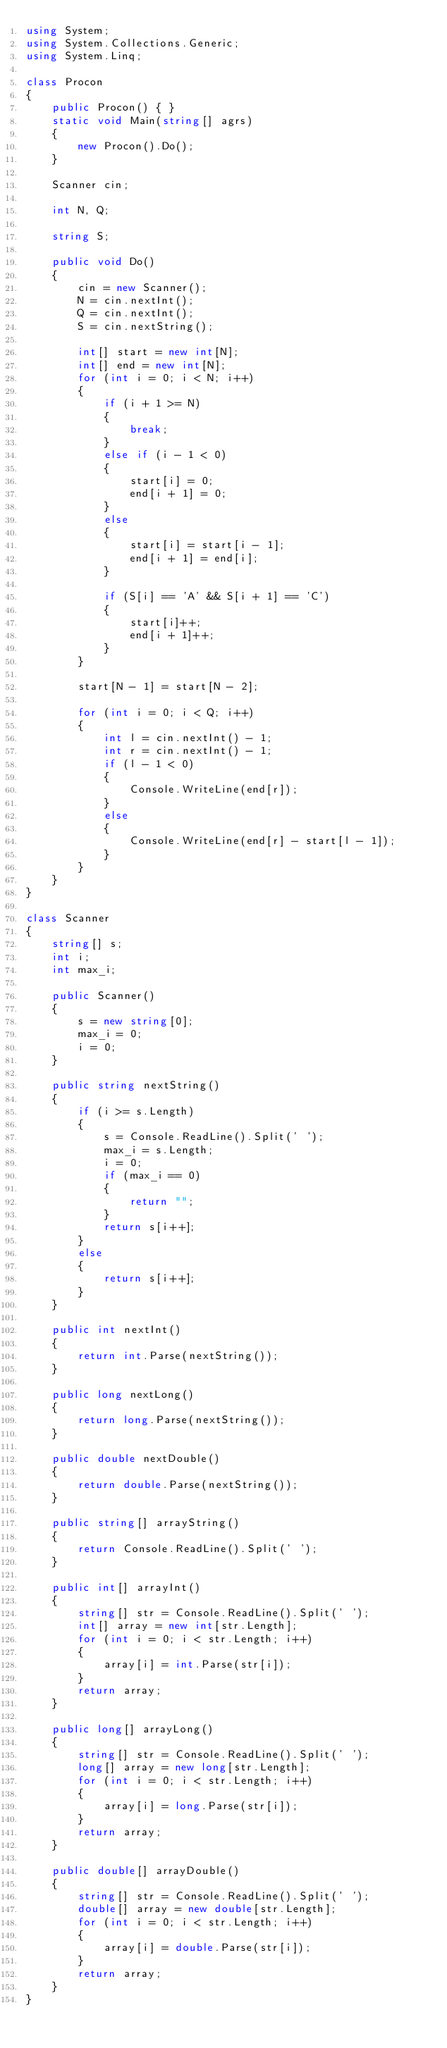<code> <loc_0><loc_0><loc_500><loc_500><_C#_>using System;
using System.Collections.Generic;
using System.Linq;

class Procon
{
    public Procon() { }
    static void Main(string[] agrs)
    {
        new Procon().Do();
    }

    Scanner cin;

    int N, Q;

    string S;

    public void Do()
    {
        cin = new Scanner();
        N = cin.nextInt();
        Q = cin.nextInt();
        S = cin.nextString();

        int[] start = new int[N];
        int[] end = new int[N];
        for (int i = 0; i < N; i++)
        {
            if (i + 1 >= N)
            {
                break;
            }
            else if (i - 1 < 0)
            {
                start[i] = 0;
                end[i + 1] = 0;
            }
            else
            {
                start[i] = start[i - 1];
                end[i + 1] = end[i];
            }

            if (S[i] == 'A' && S[i + 1] == 'C')
            {
                start[i]++;
                end[i + 1]++;
            }
        }

        start[N - 1] = start[N - 2];

        for (int i = 0; i < Q; i++)
        {
            int l = cin.nextInt() - 1;
            int r = cin.nextInt() - 1;
            if (l - 1 < 0)
            {
                Console.WriteLine(end[r]);
            }
            else
            {
                Console.WriteLine(end[r] - start[l - 1]);
            }
        }
    }
}

class Scanner
{
    string[] s;
    int i;
    int max_i;

    public Scanner()
    {
        s = new string[0];
        max_i = 0;
        i = 0;
    }

    public string nextString()
    {
        if (i >= s.Length)
        {
            s = Console.ReadLine().Split(' ');
            max_i = s.Length;
            i = 0;
            if (max_i == 0)
            {
                return "";
            }
            return s[i++];
        }
        else
        {
            return s[i++];
        }
    }

    public int nextInt()
    {
        return int.Parse(nextString());
    }

    public long nextLong()
    {
        return long.Parse(nextString());
    }

    public double nextDouble()
    {
        return double.Parse(nextString());
    }

    public string[] arrayString()
    {
        return Console.ReadLine().Split(' ');
    }

    public int[] arrayInt()
    {
        string[] str = Console.ReadLine().Split(' ');
        int[] array = new int[str.Length];
        for (int i = 0; i < str.Length; i++)
        {
            array[i] = int.Parse(str[i]);
        }
        return array;
    }

    public long[] arrayLong()
    {
        string[] str = Console.ReadLine().Split(' ');
        long[] array = new long[str.Length];
        for (int i = 0; i < str.Length; i++)
        {
            array[i] = long.Parse(str[i]);
        }
        return array;
    }

    public double[] arrayDouble()
    {
        string[] str = Console.ReadLine().Split(' ');
        double[] array = new double[str.Length];
        for (int i = 0; i < str.Length; i++)
        {
            array[i] = double.Parse(str[i]);
        }
        return array;
    }
}</code> 